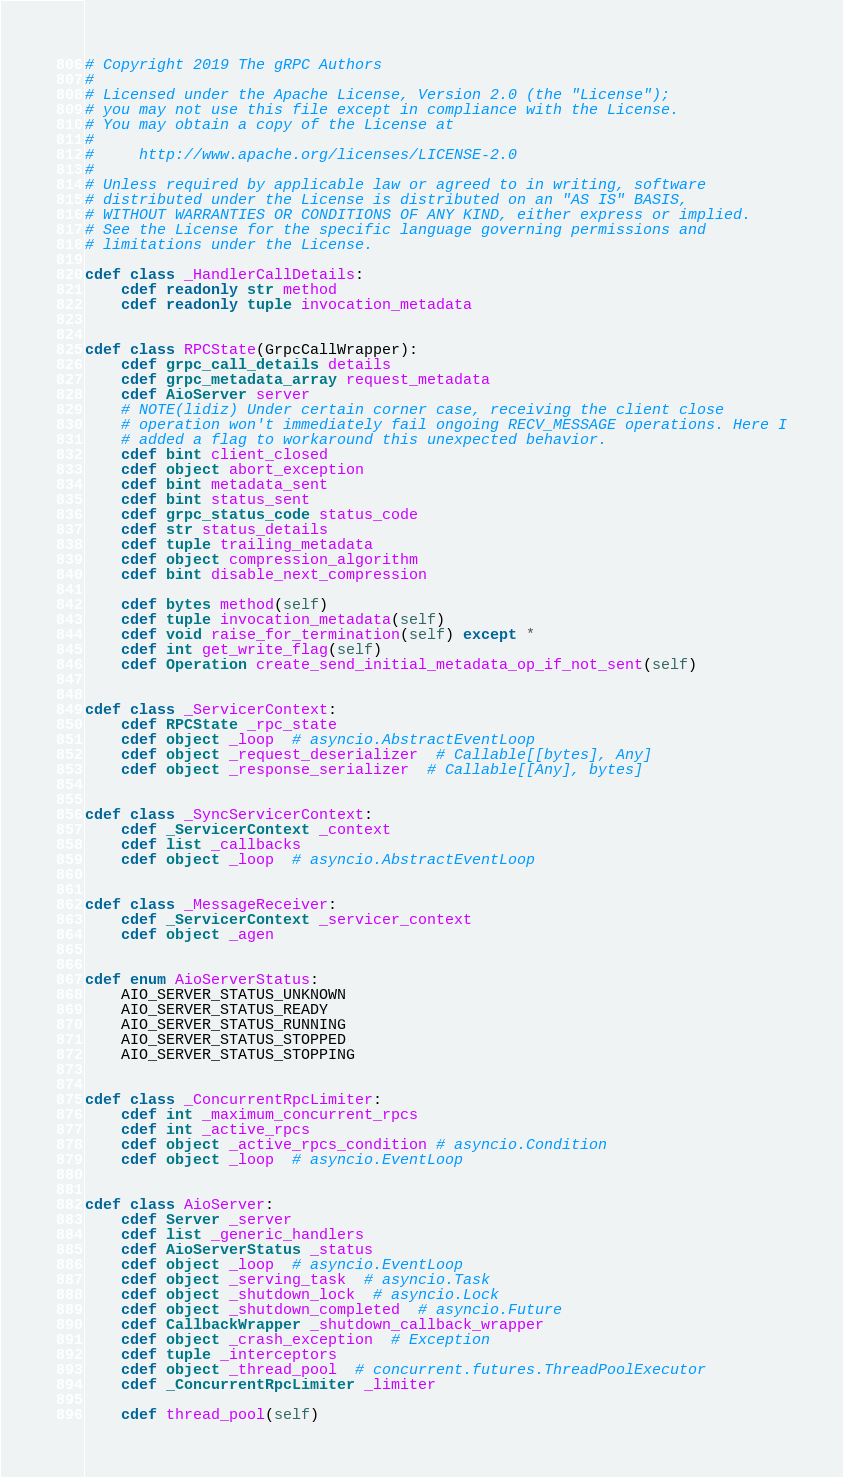Convert code to text. <code><loc_0><loc_0><loc_500><loc_500><_Cython_># Copyright 2019 The gRPC Authors
#
# Licensed under the Apache License, Version 2.0 (the "License");
# you may not use this file except in compliance with the License.
# You may obtain a copy of the License at
#
#     http://www.apache.org/licenses/LICENSE-2.0
#
# Unless required by applicable law or agreed to in writing, software
# distributed under the License is distributed on an "AS IS" BASIS,
# WITHOUT WARRANTIES OR CONDITIONS OF ANY KIND, either express or implied.
# See the License for the specific language governing permissions and
# limitations under the License.

cdef class _HandlerCallDetails:
    cdef readonly str method
    cdef readonly tuple invocation_metadata


cdef class RPCState(GrpcCallWrapper):
    cdef grpc_call_details details
    cdef grpc_metadata_array request_metadata
    cdef AioServer server
    # NOTE(lidiz) Under certain corner case, receiving the client close
    # operation won't immediately fail ongoing RECV_MESSAGE operations. Here I
    # added a flag to workaround this unexpected behavior.
    cdef bint client_closed
    cdef object abort_exception
    cdef bint metadata_sent
    cdef bint status_sent
    cdef grpc_status_code status_code
    cdef str status_details
    cdef tuple trailing_metadata
    cdef object compression_algorithm
    cdef bint disable_next_compression

    cdef bytes method(self)
    cdef tuple invocation_metadata(self)
    cdef void raise_for_termination(self) except *
    cdef int get_write_flag(self)
    cdef Operation create_send_initial_metadata_op_if_not_sent(self)


cdef class _ServicerContext:
    cdef RPCState _rpc_state
    cdef object _loop  # asyncio.AbstractEventLoop
    cdef object _request_deserializer  # Callable[[bytes], Any]
    cdef object _response_serializer  # Callable[[Any], bytes]


cdef class _SyncServicerContext:
    cdef _ServicerContext _context
    cdef list _callbacks
    cdef object _loop  # asyncio.AbstractEventLoop


cdef class _MessageReceiver:
    cdef _ServicerContext _servicer_context
    cdef object _agen


cdef enum AioServerStatus:
    AIO_SERVER_STATUS_UNKNOWN
    AIO_SERVER_STATUS_READY
    AIO_SERVER_STATUS_RUNNING
    AIO_SERVER_STATUS_STOPPED
    AIO_SERVER_STATUS_STOPPING


cdef class _ConcurrentRpcLimiter:
    cdef int _maximum_concurrent_rpcs
    cdef int _active_rpcs
    cdef object _active_rpcs_condition # asyncio.Condition
    cdef object _loop  # asyncio.EventLoop


cdef class AioServer:
    cdef Server _server
    cdef list _generic_handlers
    cdef AioServerStatus _status
    cdef object _loop  # asyncio.EventLoop
    cdef object _serving_task  # asyncio.Task
    cdef object _shutdown_lock  # asyncio.Lock
    cdef object _shutdown_completed  # asyncio.Future
    cdef CallbackWrapper _shutdown_callback_wrapper
    cdef object _crash_exception  # Exception
    cdef tuple _interceptors
    cdef object _thread_pool  # concurrent.futures.ThreadPoolExecutor
    cdef _ConcurrentRpcLimiter _limiter

    cdef thread_pool(self)
</code> 